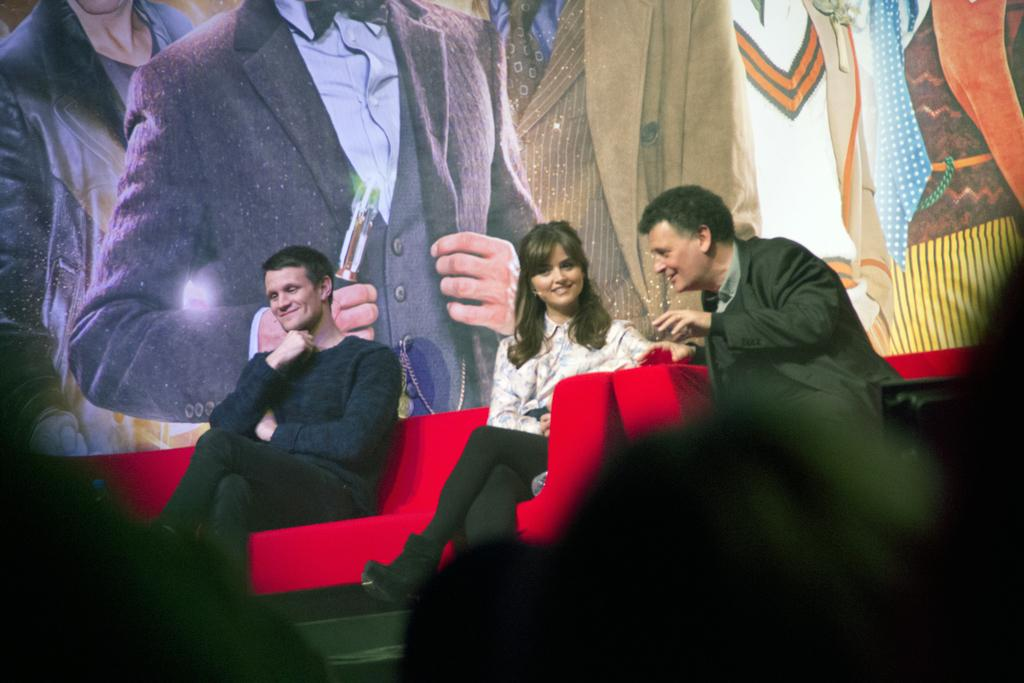What are the people in the image doing? The people in the image are sitting on a sofa. What can be seen in the background of the image? There is a poster in the background of the image. What is the value of the son's toy in the image? There is no son or toy present in the image. 